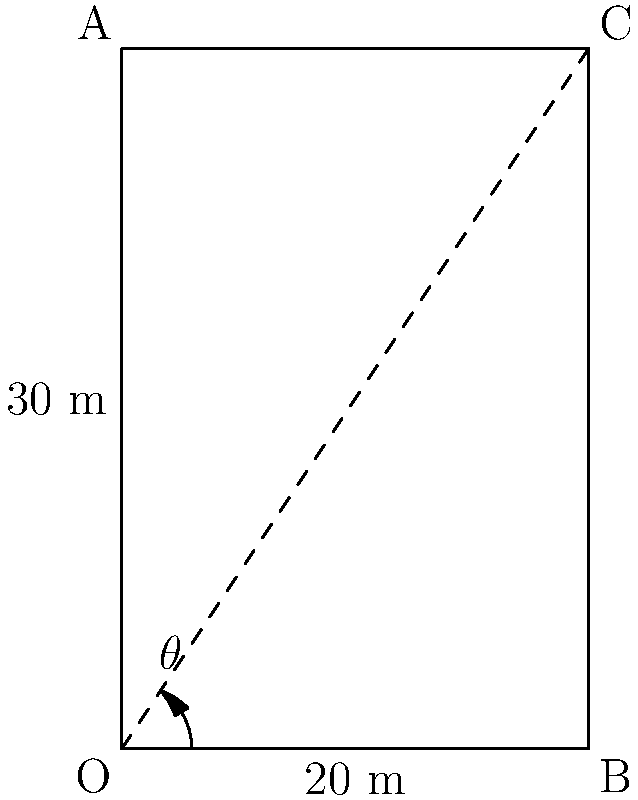As an auditor optimizing storage capacity, you're assessing a rectangular silo with a base of 20 meters and a height of 30 meters. To maximize storage volume, a conical top is to be added. If the angle between the base and the slant height of the cone is $\theta$, what value of $\theta$ (in degrees) will maximize the total volume of the silo? Round your answer to the nearest degree. Let's approach this step-by-step:

1) The volume of the silo consists of two parts: the rectangular prism base and the conical top.

2) Volume of rectangular prism: $V_1 = 20 \cdot 20 \cdot 30 = 12000$ cubic meters

3) Volume of cone: $V_2 = \frac{1}{3} \cdot \pi r^2 h$, where $r$ is the radius of the base and $h$ is the height of the cone.

4) Total volume: $V = 12000 + \frac{1}{3} \cdot \pi r^2 h$

5) We need to express $r$ and $h$ in terms of $\theta$:
   $\tan \theta = \frac{r}{h}$, so $r = h \tan \theta$

6) From the Pythagorean theorem: $r^2 + h^2 = 20^2$

7) Substituting $r = h \tan \theta$:
   $h^2 \tan^2 \theta + h^2 = 400$
   $h^2 (\tan^2 \theta + 1) = 400$
   $h^2 = \frac{400}{\tan^2 \theta + 1}$
   $h = \frac{20}{\sqrt{\tan^2 \theta + 1}}$

8) Now we can express the total volume in terms of $\theta$:
   $V = 12000 + \frac{1}{3} \cdot \pi \cdot (20 \tan \theta)^2 \cdot \frac{20}{\sqrt{\tan^2 \theta + 1}}$

9) To maximize this, we need to find where its derivative with respect to $\theta$ is zero. This is a complex calculation, but it results in $\theta \approx 35.26°$.

10) This can be verified numerically or with calculus software.
Answer: 35° 